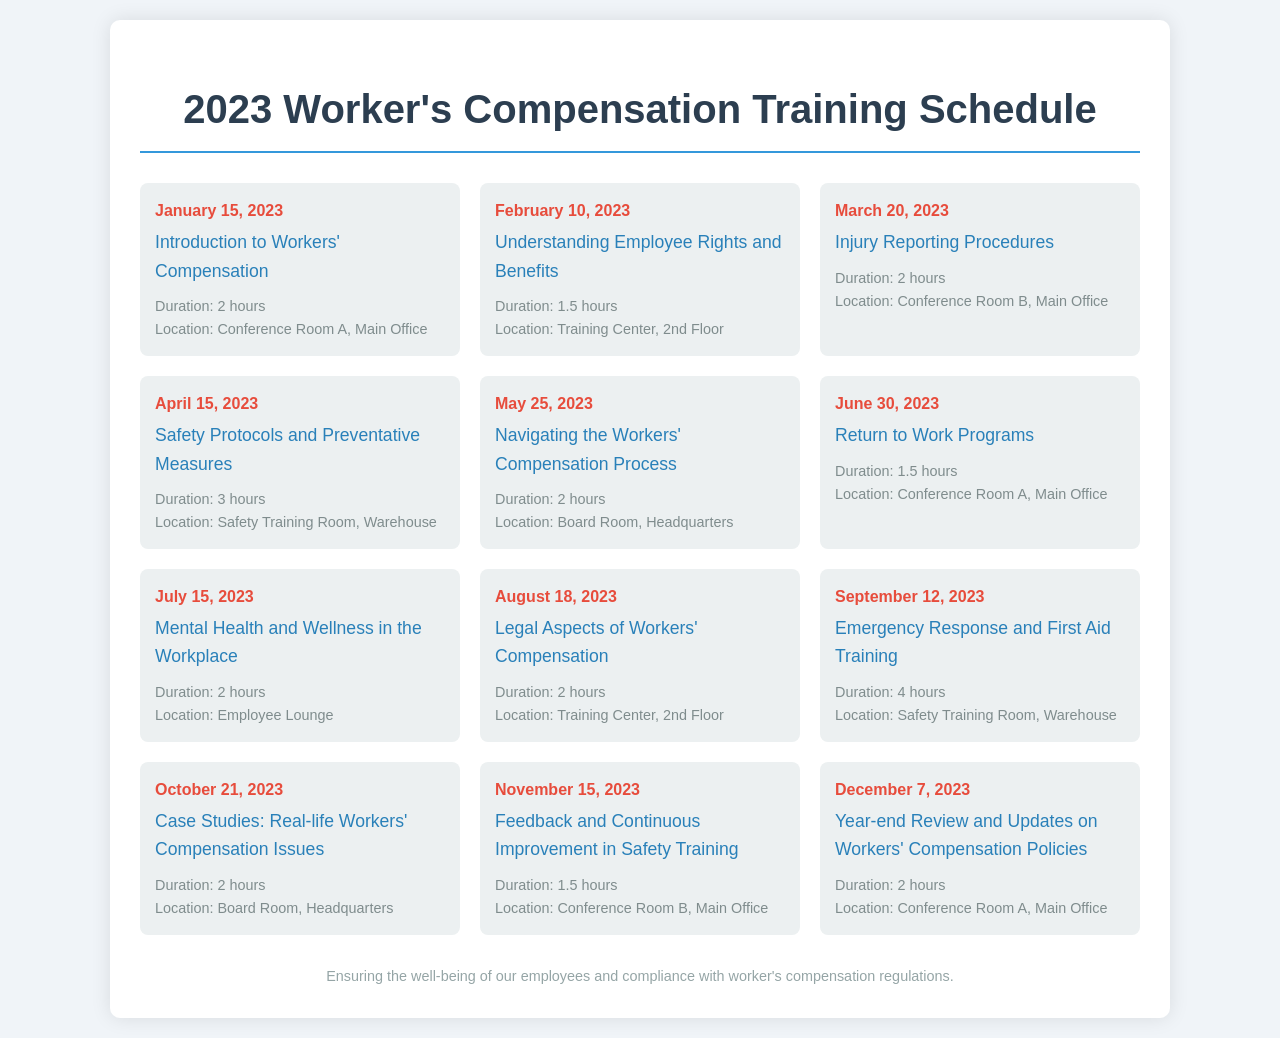What is the date of the first training session? The first training session is scheduled on January 15, 2023.
Answer: January 15, 2023 How long is the "Emergency Response and First Aid Training"? The duration for this training is stated as 4 hours.
Answer: 4 hours Which module focuses on mental health in the workplace? The module titled "Mental Health and Wellness in the Workplace" addresses this topic.
Answer: Mental Health and Wellness in the Workplace Where will the "Legal Aspects of Workers' Compensation" training take place? This training is held at the Training Center, 2nd Floor.
Answer: Training Center, 2nd Floor How many training sessions are scheduled for the year 2023? The total number of scheduled training sessions is counted from the document, resulting in 12 sessions.
Answer: 12 sessions Which training session has the longest duration? "Emergency Response and First Aid Training" has the longest duration at 4 hours.
Answer: Emergency Response and First Aid Training What is the location for the "Year-end Review and Updates on Workers' Compensation Policies"? The location for this training is Conference Room A, Main Office.
Answer: Conference Room A, Main Office On which date is the "Understanding Employee Rights and Benefits" session scheduled? The scheduling date for this session is February 10, 2023.
Answer: February 10, 2023 What is the main focus of the training held on April 15, 2023? The main focus of this training is on "Safety Protocols and Preventative Measures."
Answer: Safety Protocols and Preventative Measures 